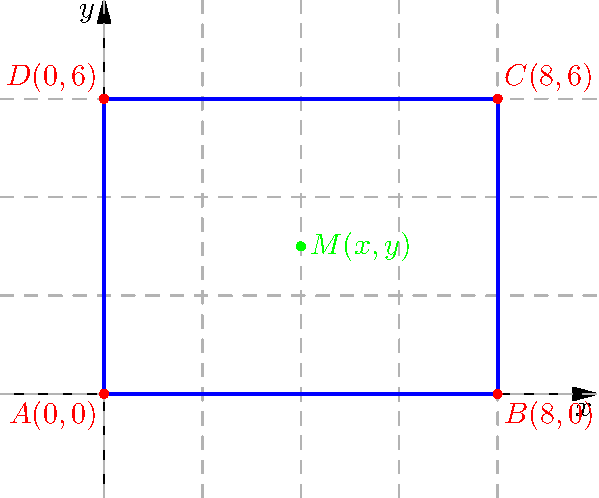As a trampoline instructor, you're designing a new rectangular trampoline for your training facility. The corners of the trampoline are represented by the following coordinates: $A(0,0)$, $B(8,0)$, $C(8,6)$, and $D(0,6)$. To ensure optimal performance and safety, you need to find the exact center of the trampoline's surface. Calculate the coordinates of the midpoint $M(x,y)$ of the trampoline's surface. To find the midpoint of the trampoline's surface, we need to follow these steps:

1) The midpoint of a rectangle is the same as the midpoint of its diagonals. We can use either diagonal AC or BD.

2) Let's use diagonal AC. The midpoint formula for two points $(x_1, y_1)$ and $(x_2, y_2)$ is:

   $M_x = \frac{x_1 + x_2}{2}$ and $M_y = \frac{y_1 + y_2}{2}$

3) For point A: $(x_1, y_1) = (0, 0)$
   For point C: $(x_2, y_2) = (8, 6)$

4) Calculating x-coordinate of M:
   $M_x = \frac{0 + 8}{2} = \frac{8}{2} = 4$

5) Calculating y-coordinate of M:
   $M_y = \frac{0 + 6}{2} = \frac{6}{2} = 3$

Therefore, the coordinates of the midpoint M are (4, 3).
Answer: $M(4,3)$ 